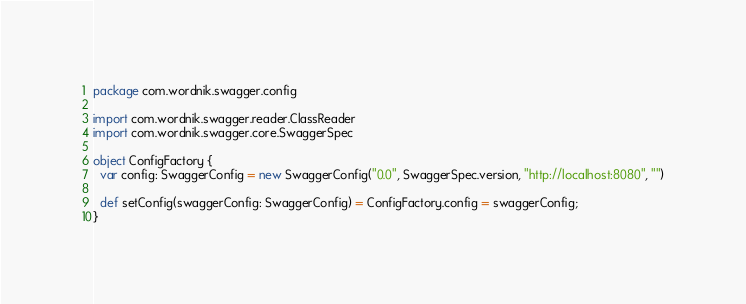Convert code to text. <code><loc_0><loc_0><loc_500><loc_500><_Scala_>package com.wordnik.swagger.config

import com.wordnik.swagger.reader.ClassReader
import com.wordnik.swagger.core.SwaggerSpec

object ConfigFactory {
  var config: SwaggerConfig = new SwaggerConfig("0.0", SwaggerSpec.version, "http://localhost:8080", "")

  def setConfig(swaggerConfig: SwaggerConfig) = ConfigFactory.config = swaggerConfig;
}
</code> 